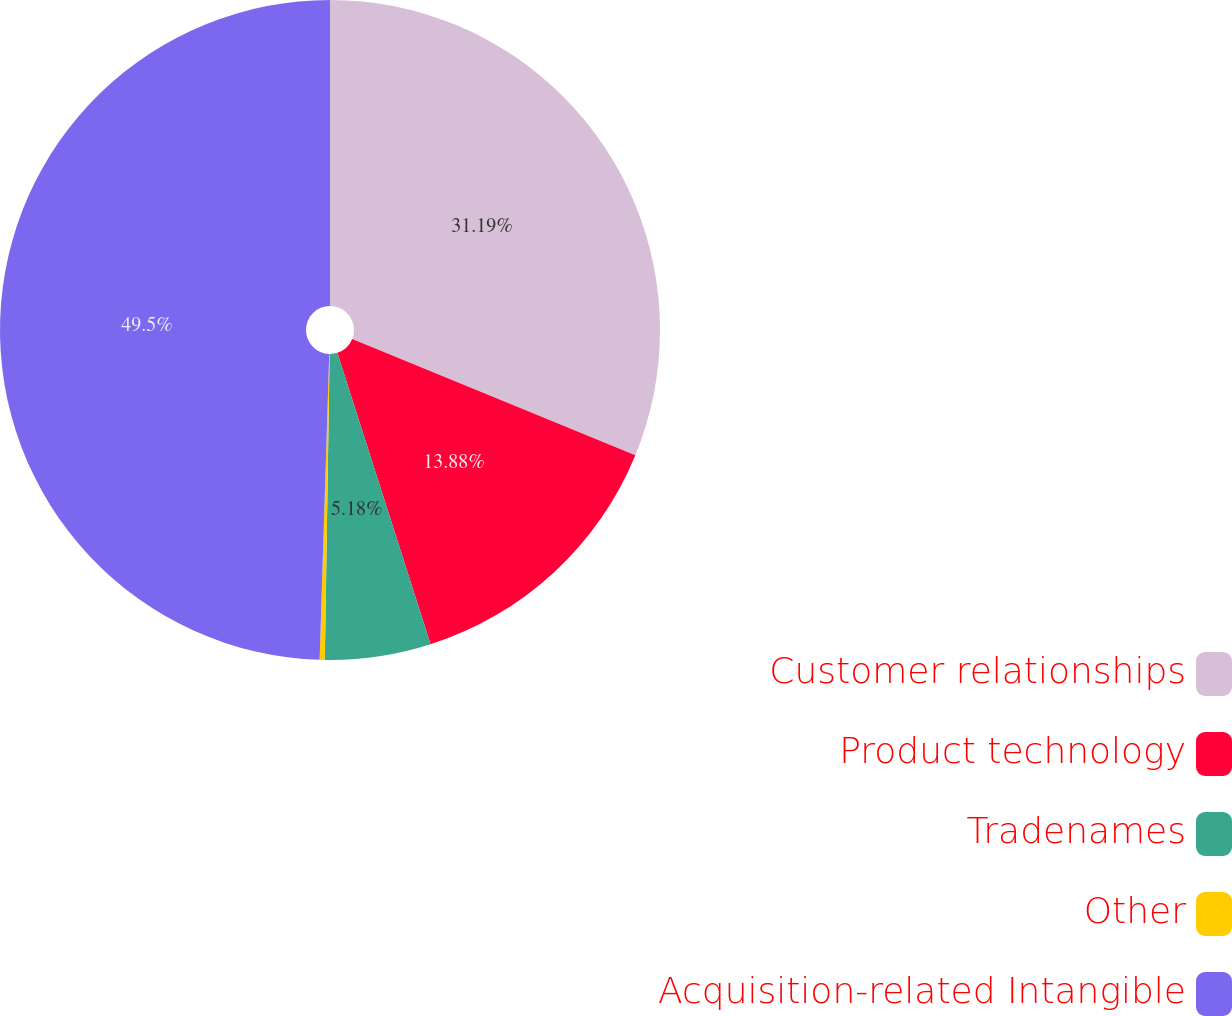<chart> <loc_0><loc_0><loc_500><loc_500><pie_chart><fcel>Customer relationships<fcel>Product technology<fcel>Tradenames<fcel>Other<fcel>Acquisition-related Intangible<nl><fcel>31.19%<fcel>13.88%<fcel>5.18%<fcel>0.25%<fcel>49.5%<nl></chart> 